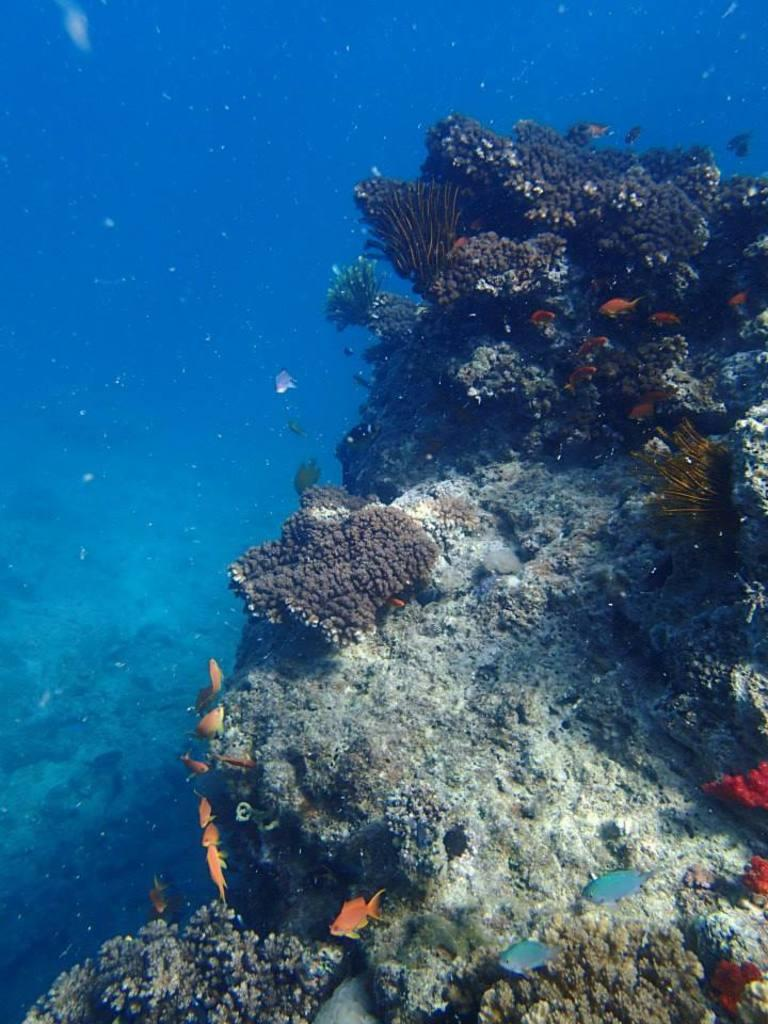Where was the picture taken? The picture was taken underwater. What natural formations can be seen in the image? There are corals and rocks in the image. What type of marine life is visible in the image? Fish are visible in the image. What are the fish doing in the image? The fish are moving in the water. Is there a fan visible in the image? No, there is no fan present in the image, as it was taken underwater and fans are not typically found in that environment. 